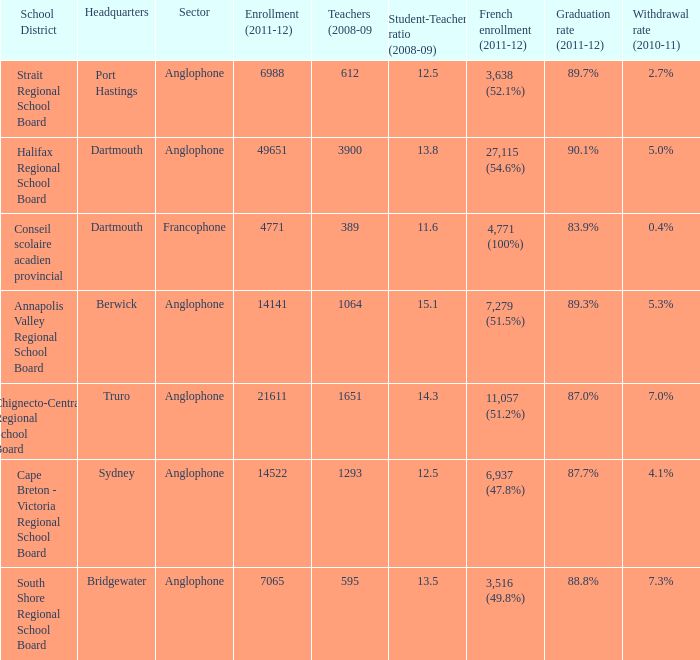Give me the full table as a dictionary. {'header': ['School District', 'Headquarters', 'Sector', 'Enrollment (2011-12)', 'Teachers (2008-09', 'Student-Teacher ratio (2008-09)', 'French enrollment (2011-12)', 'Graduation rate (2011-12)', 'Withdrawal rate (2010-11)'], 'rows': [['Strait Regional School Board', 'Port Hastings', 'Anglophone', '6988', '612', '12.5', '3,638 (52.1%)', '89.7%', '2.7%'], ['Halifax Regional School Board', 'Dartmouth', 'Anglophone', '49651', '3900', '13.8', '27,115 (54.6%)', '90.1%', '5.0%'], ['Conseil scolaire acadien provincial', 'Dartmouth', 'Francophone', '4771', '389', '11.6', '4,771 (100%)', '83.9%', '0.4%'], ['Annapolis Valley Regional School Board', 'Berwick', 'Anglophone', '14141', '1064', '15.1', '7,279 (51.5%)', '89.3%', '5.3%'], ['Chignecto-Central Regional School Board', 'Truro', 'Anglophone', '21611', '1651', '14.3', '11,057 (51.2%)', '87.0%', '7.0%'], ['Cape Breton - Victoria Regional School Board', 'Sydney', 'Anglophone', '14522', '1293', '12.5', '6,937 (47.8%)', '87.7%', '4.1%'], ['South Shore Regional School Board', 'Bridgewater', 'Anglophone', '7065', '595', '13.5', '3,516 (49.8%)', '88.8%', '7.3%']]} What is their withdrawal rate for the school district with headquarters located in Truro? 7.0%. 